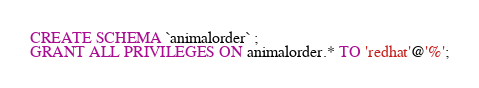<code> <loc_0><loc_0><loc_500><loc_500><_SQL_>CREATE SCHEMA `animalorder` ;
GRANT ALL PRIVILEGES ON animalorder.* TO 'redhat'@'%';</code> 